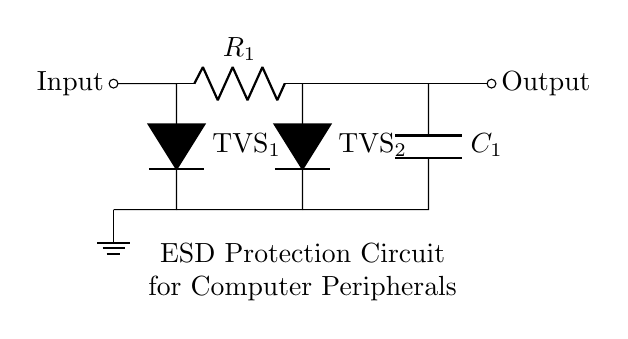What is the main function of the component labeled TVS1? The component labeled TVS1 is a Transient Voltage Suppressor, which is used to protect the circuit from voltage spikes.
Answer: Transient Voltage Suppressor What type of connection is used for the input? The input is connected by a short line indicating a direct connection, representing a signal entering the circuit.
Answer: Short line How many resistors are present in the circuit? There is one resistor labeled R1 in the circuit diagram.
Answer: One Which component is located directly before the output? The component directly before the output is the resistor R1.
Answer: Resistor R1 What is the purpose of the capacitor C1 in this circuit? Capacitor C1 is used for filtering and smoothing any voltage spikes, providing additional ESD protection in parallel with the other components.
Answer: Filtering and smoothing Which two components are connected in series? The components R1 and TVS2 are connected in series between the input and output, allowing for cumulative voltage protection.
Answer: R1 and TVS2 